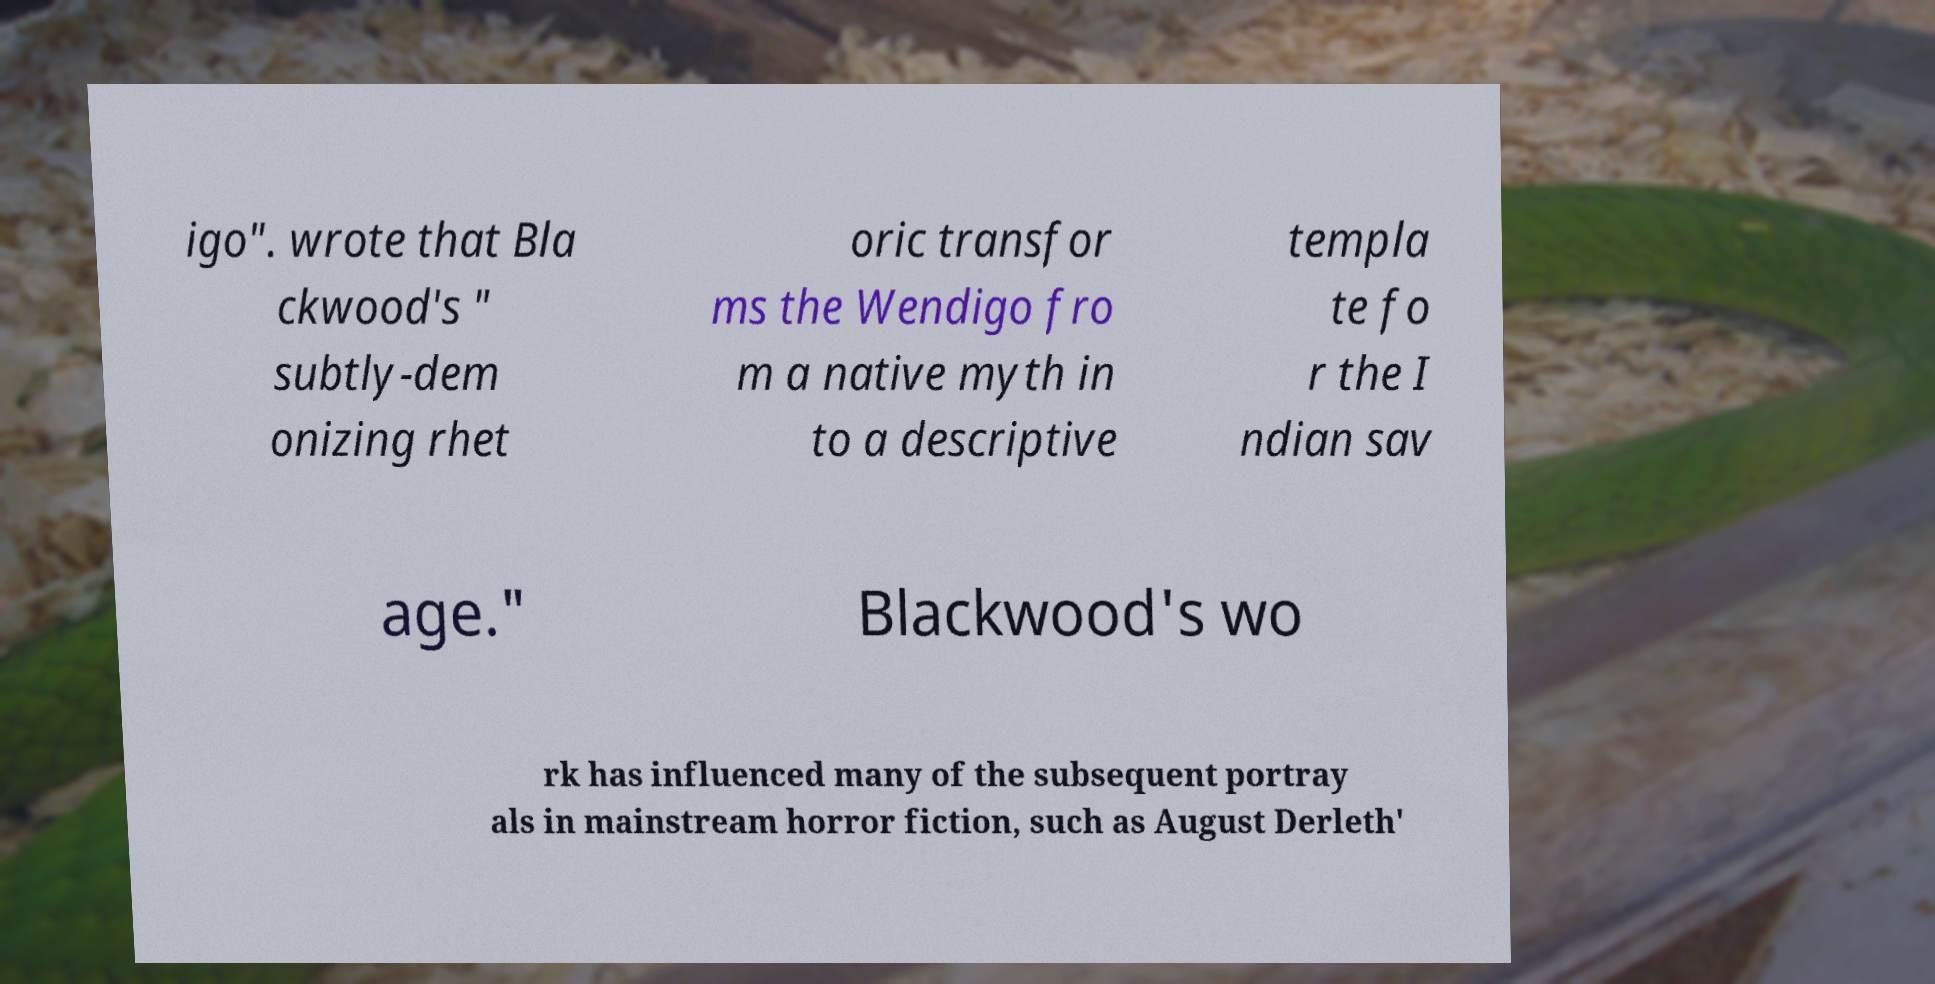Could you extract and type out the text from this image? igo". wrote that Bla ckwood's " subtly-dem onizing rhet oric transfor ms the Wendigo fro m a native myth in to a descriptive templa te fo r the I ndian sav age." Blackwood's wo rk has influenced many of the subsequent portray als in mainstream horror fiction, such as August Derleth' 